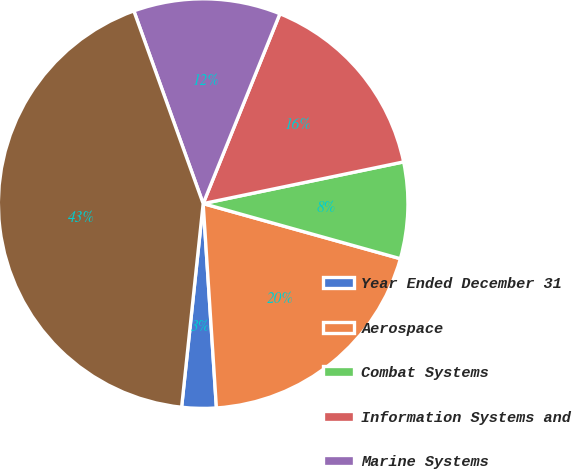Convert chart to OTSL. <chart><loc_0><loc_0><loc_500><loc_500><pie_chart><fcel>Year Ended December 31<fcel>Aerospace<fcel>Combat Systems<fcel>Information Systems and<fcel>Marine Systems<fcel>Total<nl><fcel>2.71%<fcel>19.63%<fcel>7.6%<fcel>15.62%<fcel>11.61%<fcel>42.82%<nl></chart> 